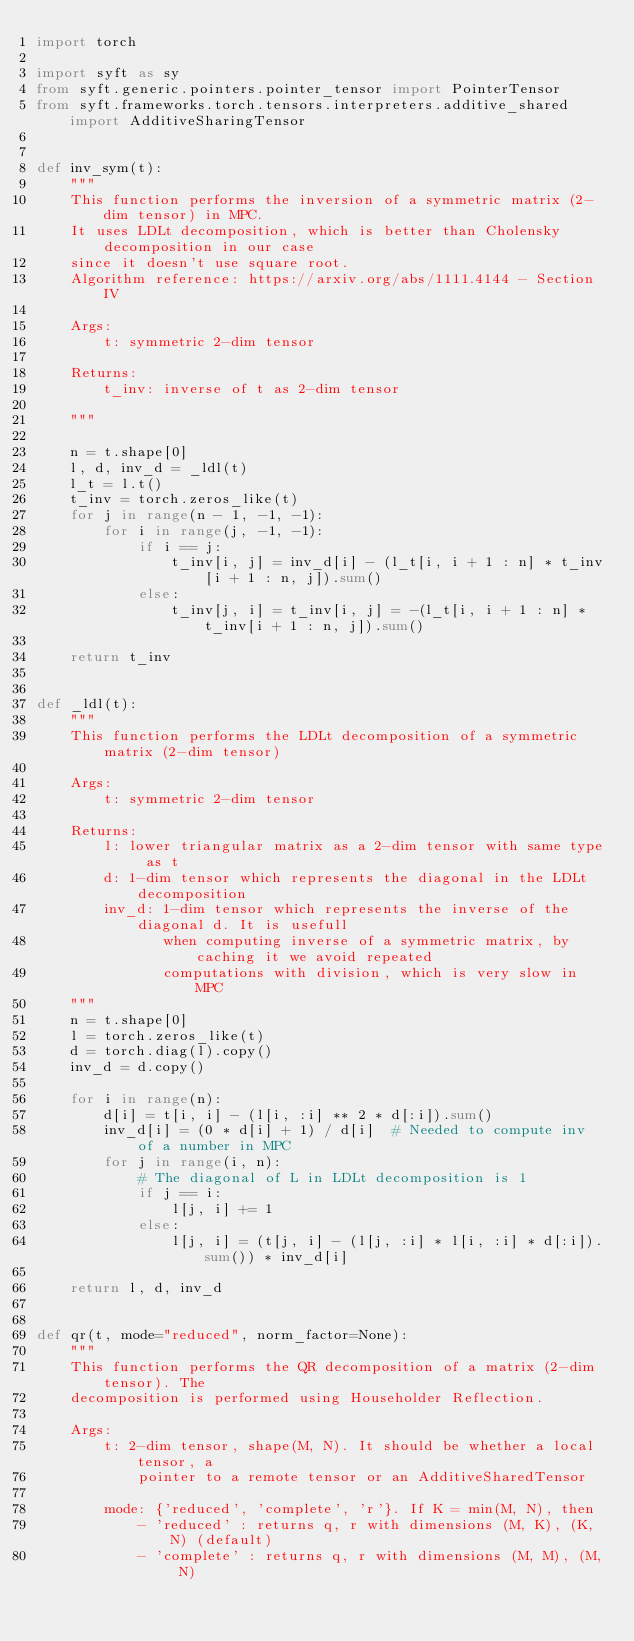<code> <loc_0><loc_0><loc_500><loc_500><_Python_>import torch

import syft as sy
from syft.generic.pointers.pointer_tensor import PointerTensor
from syft.frameworks.torch.tensors.interpreters.additive_shared import AdditiveSharingTensor


def inv_sym(t):
    """
    This function performs the inversion of a symmetric matrix (2-dim tensor) in MPC.
    It uses LDLt decomposition, which is better than Cholensky decomposition in our case
    since it doesn't use square root.
    Algorithm reference: https://arxiv.org/abs/1111.4144 - Section IV

    Args:
        t: symmetric 2-dim tensor

    Returns:
        t_inv: inverse of t as 2-dim tensor

    """

    n = t.shape[0]
    l, d, inv_d = _ldl(t)
    l_t = l.t()
    t_inv = torch.zeros_like(t)
    for j in range(n - 1, -1, -1):
        for i in range(j, -1, -1):
            if i == j:
                t_inv[i, j] = inv_d[i] - (l_t[i, i + 1 : n] * t_inv[i + 1 : n, j]).sum()
            else:
                t_inv[j, i] = t_inv[i, j] = -(l_t[i, i + 1 : n] * t_inv[i + 1 : n, j]).sum()

    return t_inv


def _ldl(t):
    """
    This function performs the LDLt decomposition of a symmetric matrix (2-dim tensor)

    Args:
        t: symmetric 2-dim tensor

    Returns:
        l: lower triangular matrix as a 2-dim tensor with same type as t
        d: 1-dim tensor which represents the diagonal in the LDLt decomposition
        inv_d: 1-dim tensor which represents the inverse of the diagonal d. It is usefull
               when computing inverse of a symmetric matrix, by caching it we avoid repeated
               computations with division, which is very slow in MPC
    """
    n = t.shape[0]
    l = torch.zeros_like(t)
    d = torch.diag(l).copy()
    inv_d = d.copy()

    for i in range(n):
        d[i] = t[i, i] - (l[i, :i] ** 2 * d[:i]).sum()
        inv_d[i] = (0 * d[i] + 1) / d[i]  # Needed to compute inv of a number in MPC
        for j in range(i, n):
            # The diagonal of L in LDLt decomposition is 1
            if j == i:
                l[j, i] += 1
            else:
                l[j, i] = (t[j, i] - (l[j, :i] * l[i, :i] * d[:i]).sum()) * inv_d[i]

    return l, d, inv_d


def qr(t, mode="reduced", norm_factor=None):
    """
    This function performs the QR decomposition of a matrix (2-dim tensor). The
    decomposition is performed using Householder Reflection.

    Args:
        t: 2-dim tensor, shape(M, N). It should be whether a local tensor, a
            pointer to a remote tensor or an AdditiveSharedTensor

        mode: {'reduced', 'complete', 'r'}. If K = min(M, N), then
            - 'reduced' : returns q, r with dimensions (M, K), (K, N) (default)
            - 'complete' : returns q, r with dimensions (M, M), (M, N)</code> 